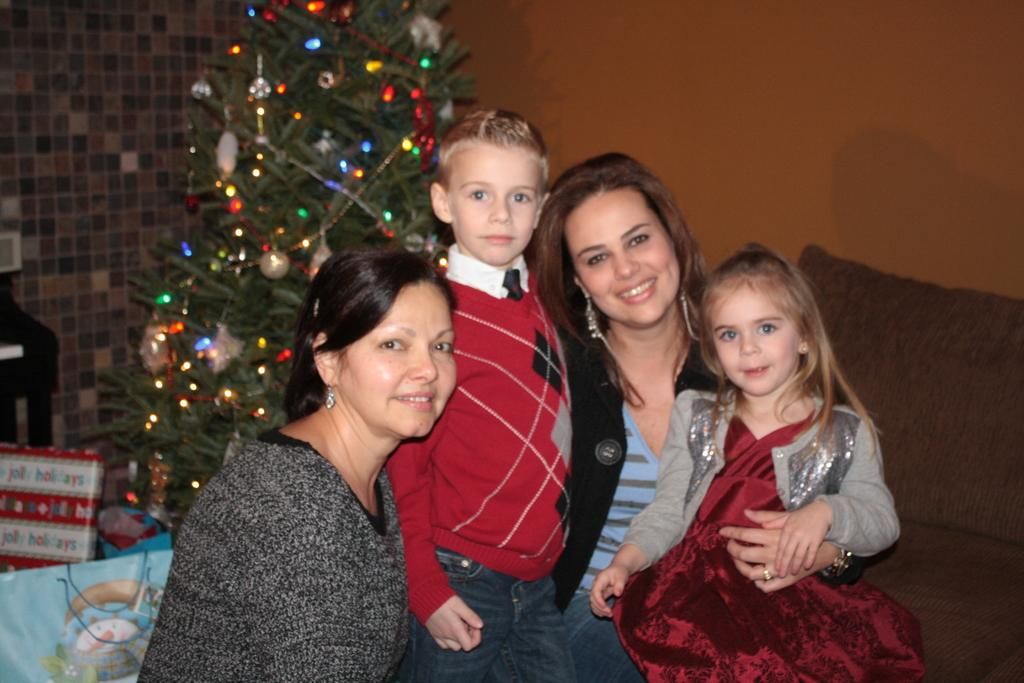What is the main object in the image? There is a Christmas tree in the image. How is the Christmas tree decorated? The Christmas tree is decorated with lights. Who are the people in the image? There are women, a boy, and a girl in the image. What are the individuals doing in the image? The individuals are giving a pose. What is the facial expression of the people in the image? All the individuals are smiling. What type of calculator can be seen on the Christmas tree in the image? There is no calculator present on the Christmas tree or in the image. Can you see any sea creatures in the image? There are no sea creatures present in the image. 